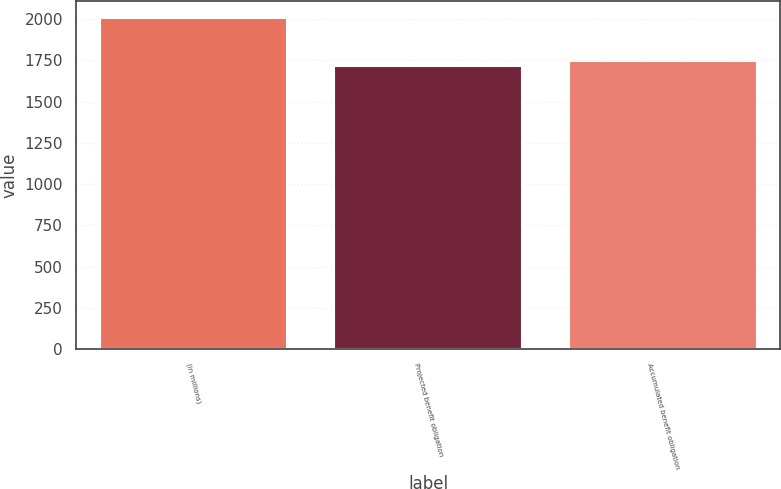Convert chart to OTSL. <chart><loc_0><loc_0><loc_500><loc_500><bar_chart><fcel>(in millions)<fcel>Projected benefit obligation<fcel>Accumulated benefit obligation<nl><fcel>2010<fcel>1716<fcel>1745.4<nl></chart> 